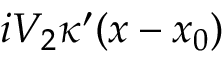<formula> <loc_0><loc_0><loc_500><loc_500>i V _ { 2 } \kappa ^ { \prime } ( x - x _ { 0 } )</formula> 